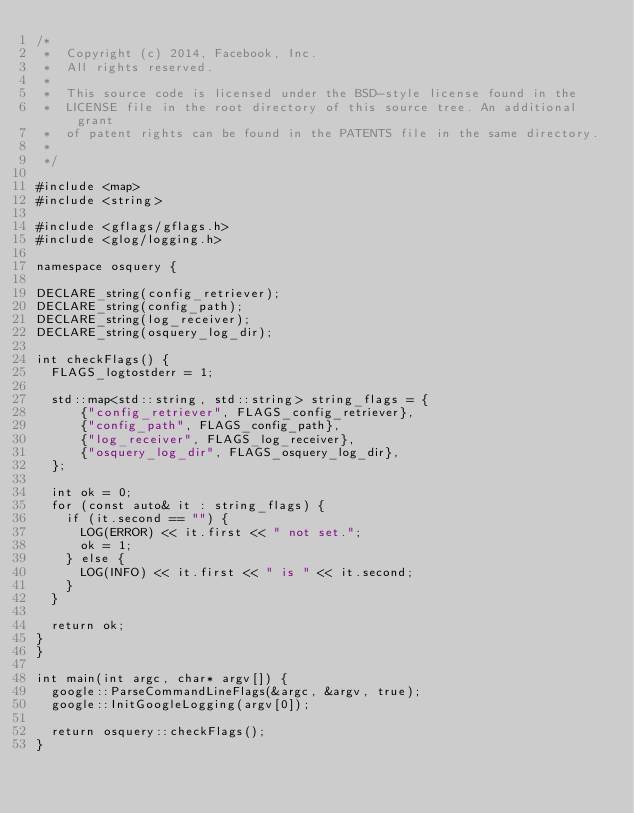<code> <loc_0><loc_0><loc_500><loc_500><_C++_>/*
 *  Copyright (c) 2014, Facebook, Inc.
 *  All rights reserved.
 *
 *  This source code is licensed under the BSD-style license found in the
 *  LICENSE file in the root directory of this source tree. An additional grant 
 *  of patent rights can be found in the PATENTS file in the same directory.
 *
 */

#include <map>
#include <string>

#include <gflags/gflags.h>
#include <glog/logging.h>

namespace osquery {

DECLARE_string(config_retriever);
DECLARE_string(config_path);
DECLARE_string(log_receiver);
DECLARE_string(osquery_log_dir);

int checkFlags() {
  FLAGS_logtostderr = 1;

  std::map<std::string, std::string> string_flags = {
      {"config_retriever", FLAGS_config_retriever},
      {"config_path", FLAGS_config_path},
      {"log_receiver", FLAGS_log_receiver},
      {"osquery_log_dir", FLAGS_osquery_log_dir},
  };

  int ok = 0;
  for (const auto& it : string_flags) {
    if (it.second == "") {
      LOG(ERROR) << it.first << " not set.";
      ok = 1;
    } else {
      LOG(INFO) << it.first << " is " << it.second;
    }
  }

  return ok;
}
}

int main(int argc, char* argv[]) {
  google::ParseCommandLineFlags(&argc, &argv, true);
  google::InitGoogleLogging(argv[0]);

  return osquery::checkFlags();
}
</code> 